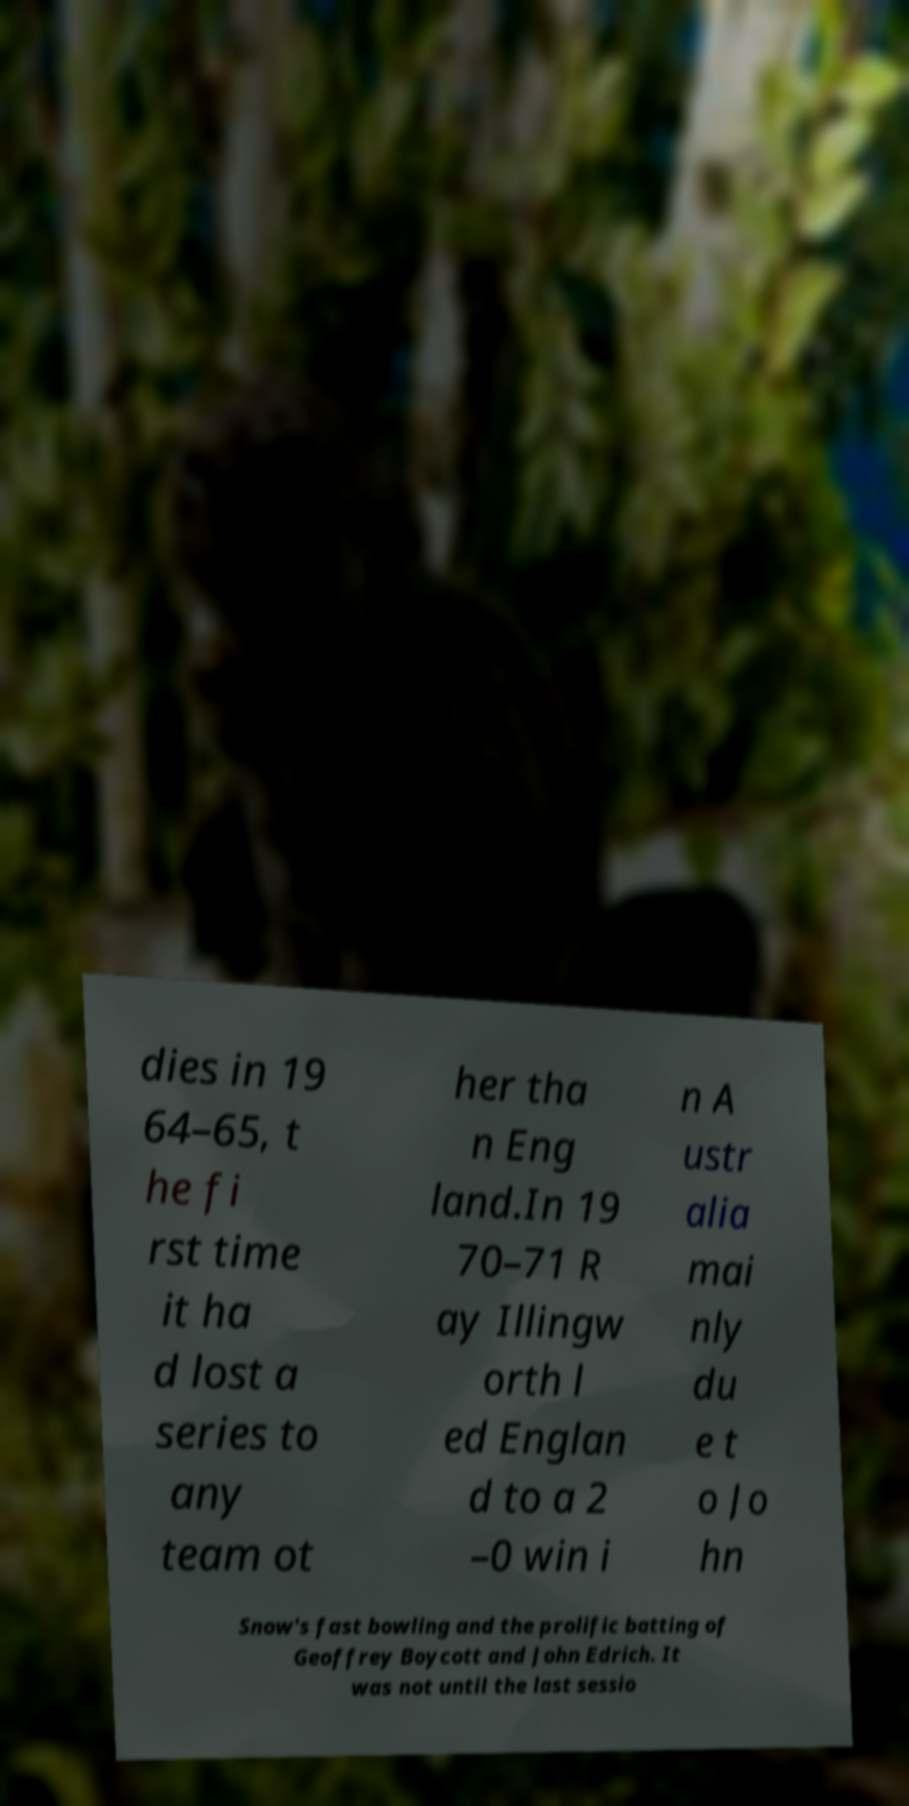Please identify and transcribe the text found in this image. dies in 19 64–65, t he fi rst time it ha d lost a series to any team ot her tha n Eng land.In 19 70–71 R ay Illingw orth l ed Englan d to a 2 –0 win i n A ustr alia mai nly du e t o Jo hn Snow's fast bowling and the prolific batting of Geoffrey Boycott and John Edrich. It was not until the last sessio 